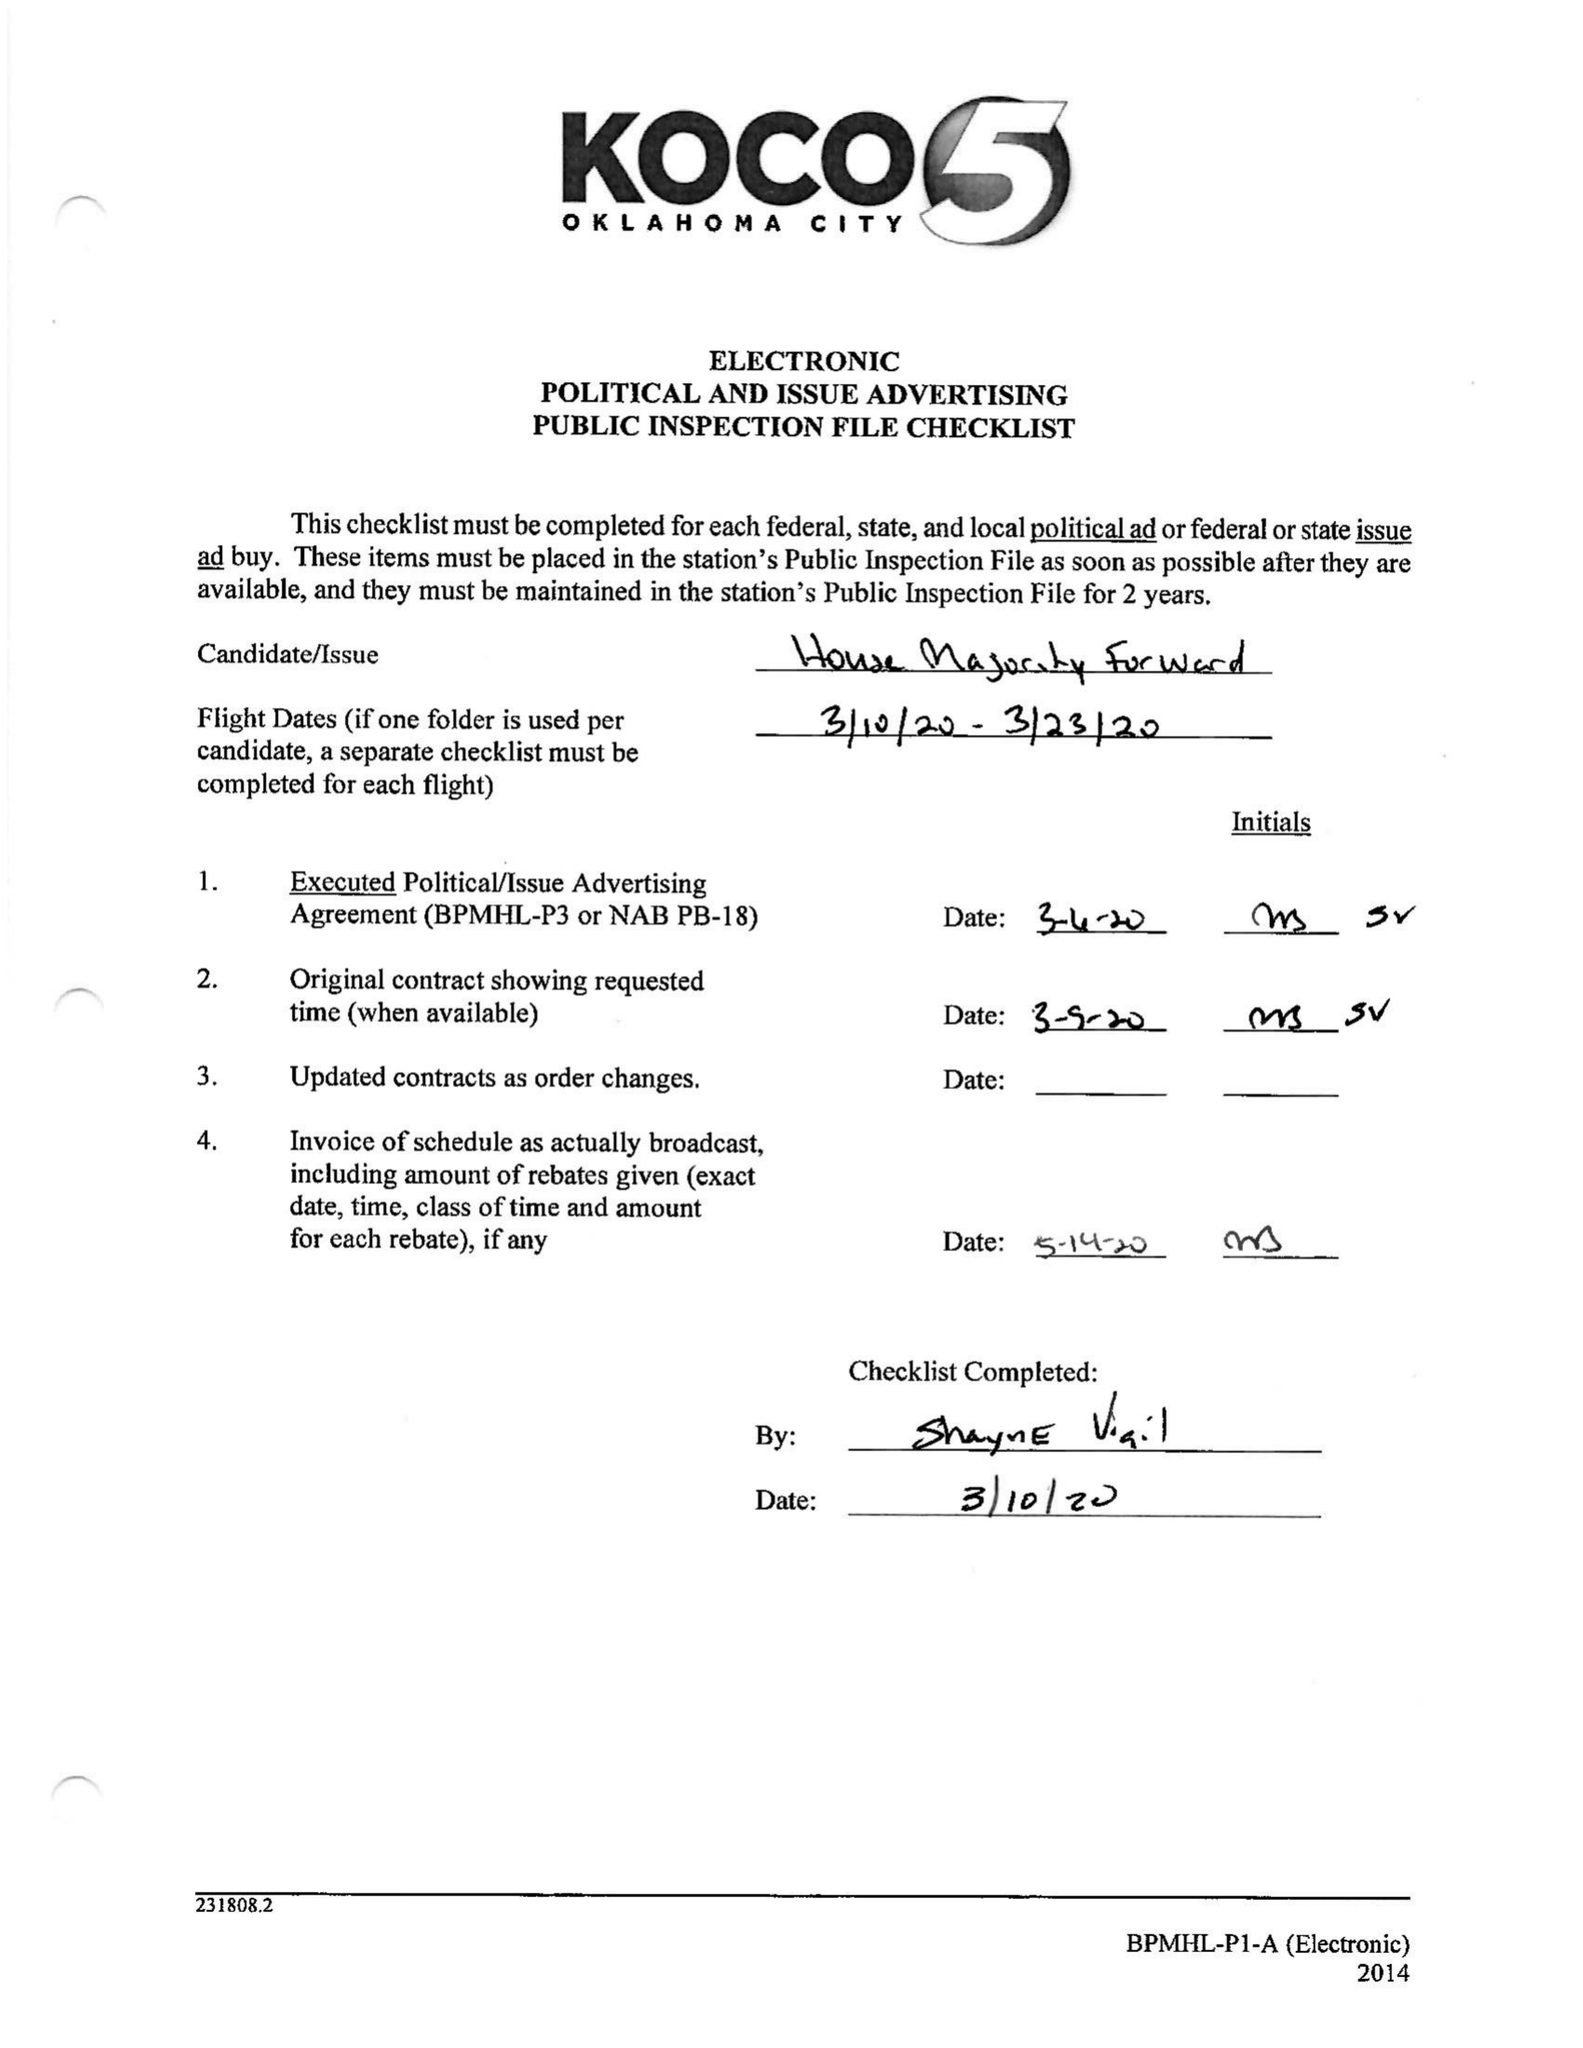What is the value for the gross_amount?
Answer the question using a single word or phrase. 16500.00 